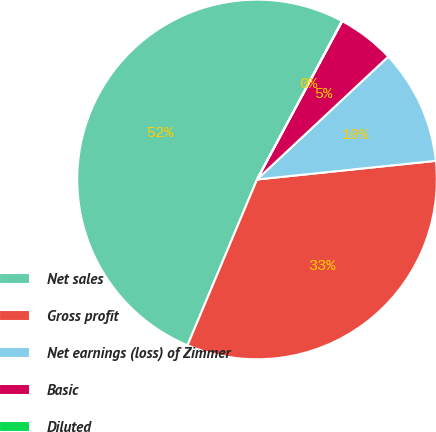Convert chart. <chart><loc_0><loc_0><loc_500><loc_500><pie_chart><fcel>Net sales<fcel>Gross profit<fcel>Net earnings (loss) of Zimmer<fcel>Basic<fcel>Diluted<nl><fcel>51.52%<fcel>32.97%<fcel>10.32%<fcel>5.17%<fcel>0.02%<nl></chart> 